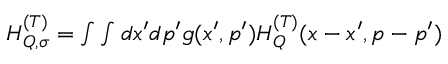<formula> <loc_0><loc_0><loc_500><loc_500>\begin{array} { r } { H _ { Q , \sigma } ^ { ( T ) } = \int \int d x ^ { \prime } d p ^ { \prime } g ( x ^ { \prime } , p ^ { \prime } ) H _ { Q } ^ { ( T ) } ( x - x ^ { \prime } , p - p ^ { \prime } ) } \end{array}</formula> 